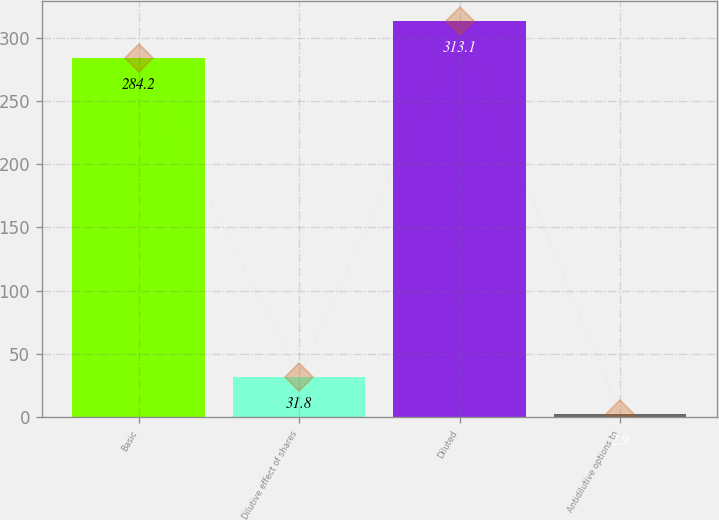Convert chart to OTSL. <chart><loc_0><loc_0><loc_500><loc_500><bar_chart><fcel>Basic<fcel>Dilutive effect of shares<fcel>Diluted<fcel>Antidilutive options to<nl><fcel>284.2<fcel>31.8<fcel>313.1<fcel>2.9<nl></chart> 